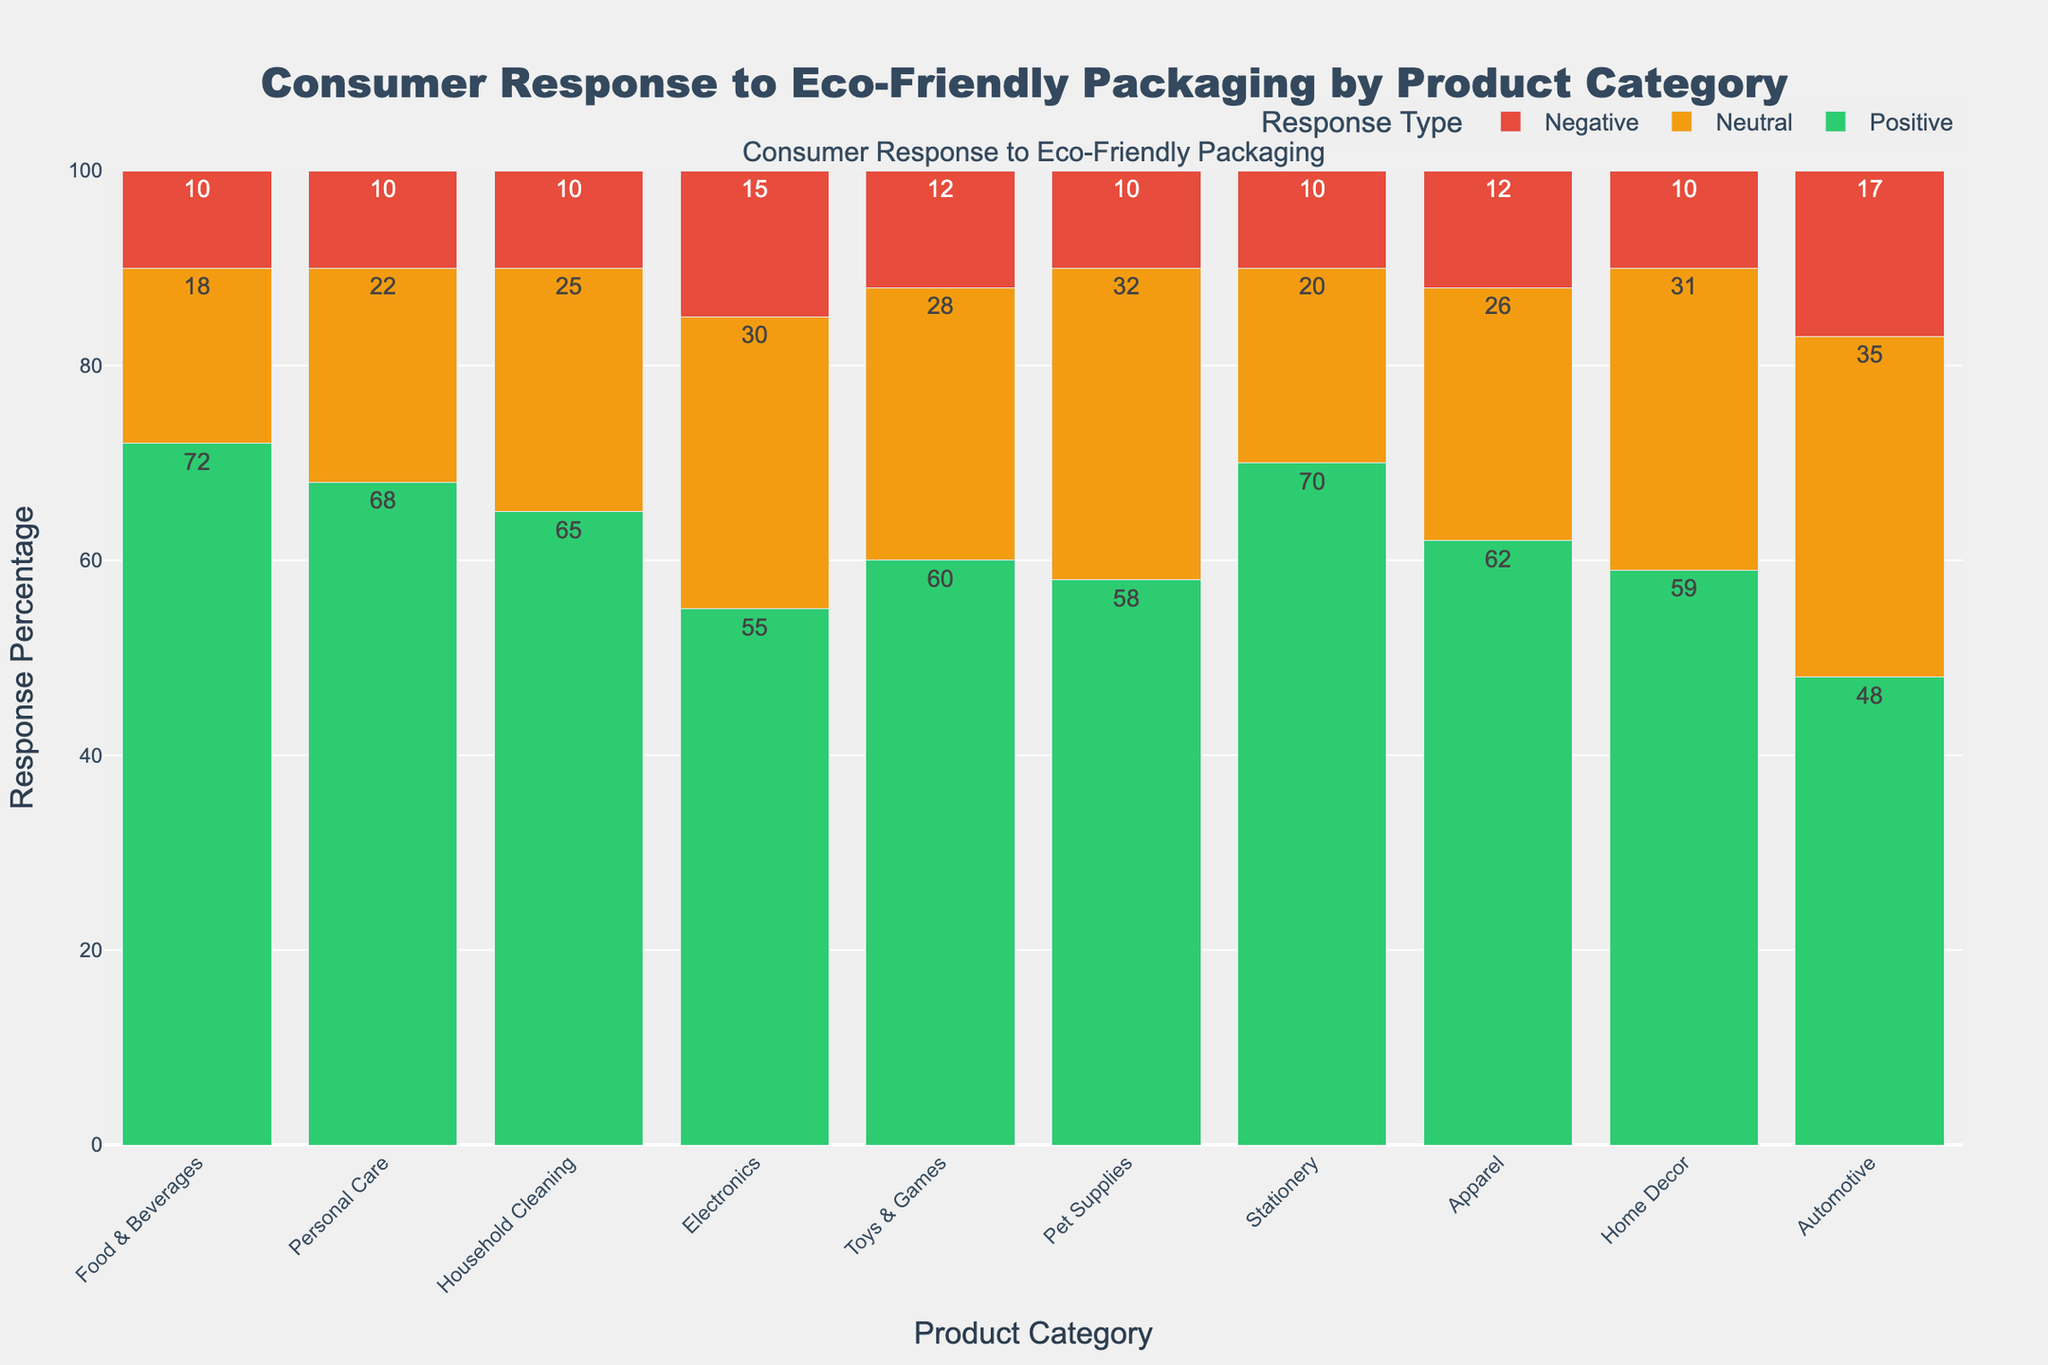What's the overall sentiment towards eco-friendly packaging in the 'Food & Beverages' category? The figure shows three responses for each category. For 'Food & Beverages,' the positive response is 72%, neutral is 18%, and negative is 10%. The overall sentiment can be gauged by noting that the positive response is much higher than neutral and negative.
Answer: Mostly positive Which product category has the highest negative response towards eco-friendly packaging? By looking at the height of the red bars corresponding to negative responses, the 'Automotive' category has the highest negative response at 17%.
Answer: Automotive How does the neutral response for 'Electronics' compare to that for 'Household Cleaning'? The figure shows that the neutral response for 'Electronics' is 30%, while for 'Household Cleaning,' it is 25%. Therefore, the neutral response for 'Electronics' is higher.
Answer: Electronics has a higher neutral response Which category shows the closest balance between positive and neutral responses? We need to identify the bars where the difference between positive and neutral responses is least. 'Pet Supplies' has positive at 58% and neutral at 32%, showing a narrow gap compared to other categories.
Answer: Pet Supplies What is the combined percentage of positive and neutral responses for 'Apparel'? Summing the positive and neutral responses for 'Apparel,' we get 62% + 26% = 88%.
Answer: 88% Compare positive responses in 'Personal Care' and 'Home Decor'. Which one is higher? The positive response for 'Personal Care' is 68%, while for 'Home Decor,' it is 59%. 'Personal Care' has a higher positive response.
Answer: Personal Care What is the difference between the negative responses for 'Toys & Games' and 'Automotive'? The negative response for 'Toys & Games' is 12%, and for 'Automotive,' it is 17%. The difference is 17% - 12% = 5%.
Answer: 5% In which category are the consumers most indifferent (neutral response) to eco-friendly packaging? By comparing the heights of the yellow bars representing neutral responses, 'Automotive' stands out with the highest neutral response at 35%.
Answer: Automotive Which product category has the most positive consumer response to eco-friendly packaging? The height of the green bars indicates positive responses. 'Food & Beverages' has the highest positive response at 72%.
Answer: Food & Beverages 